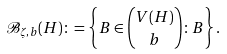<formula> <loc_0><loc_0><loc_500><loc_500>\mathcal { B } _ { \zeta , b } ( H ) \colon = \left \{ B \in \binom { V ( H ) } { b } \colon B \right \} .</formula> 